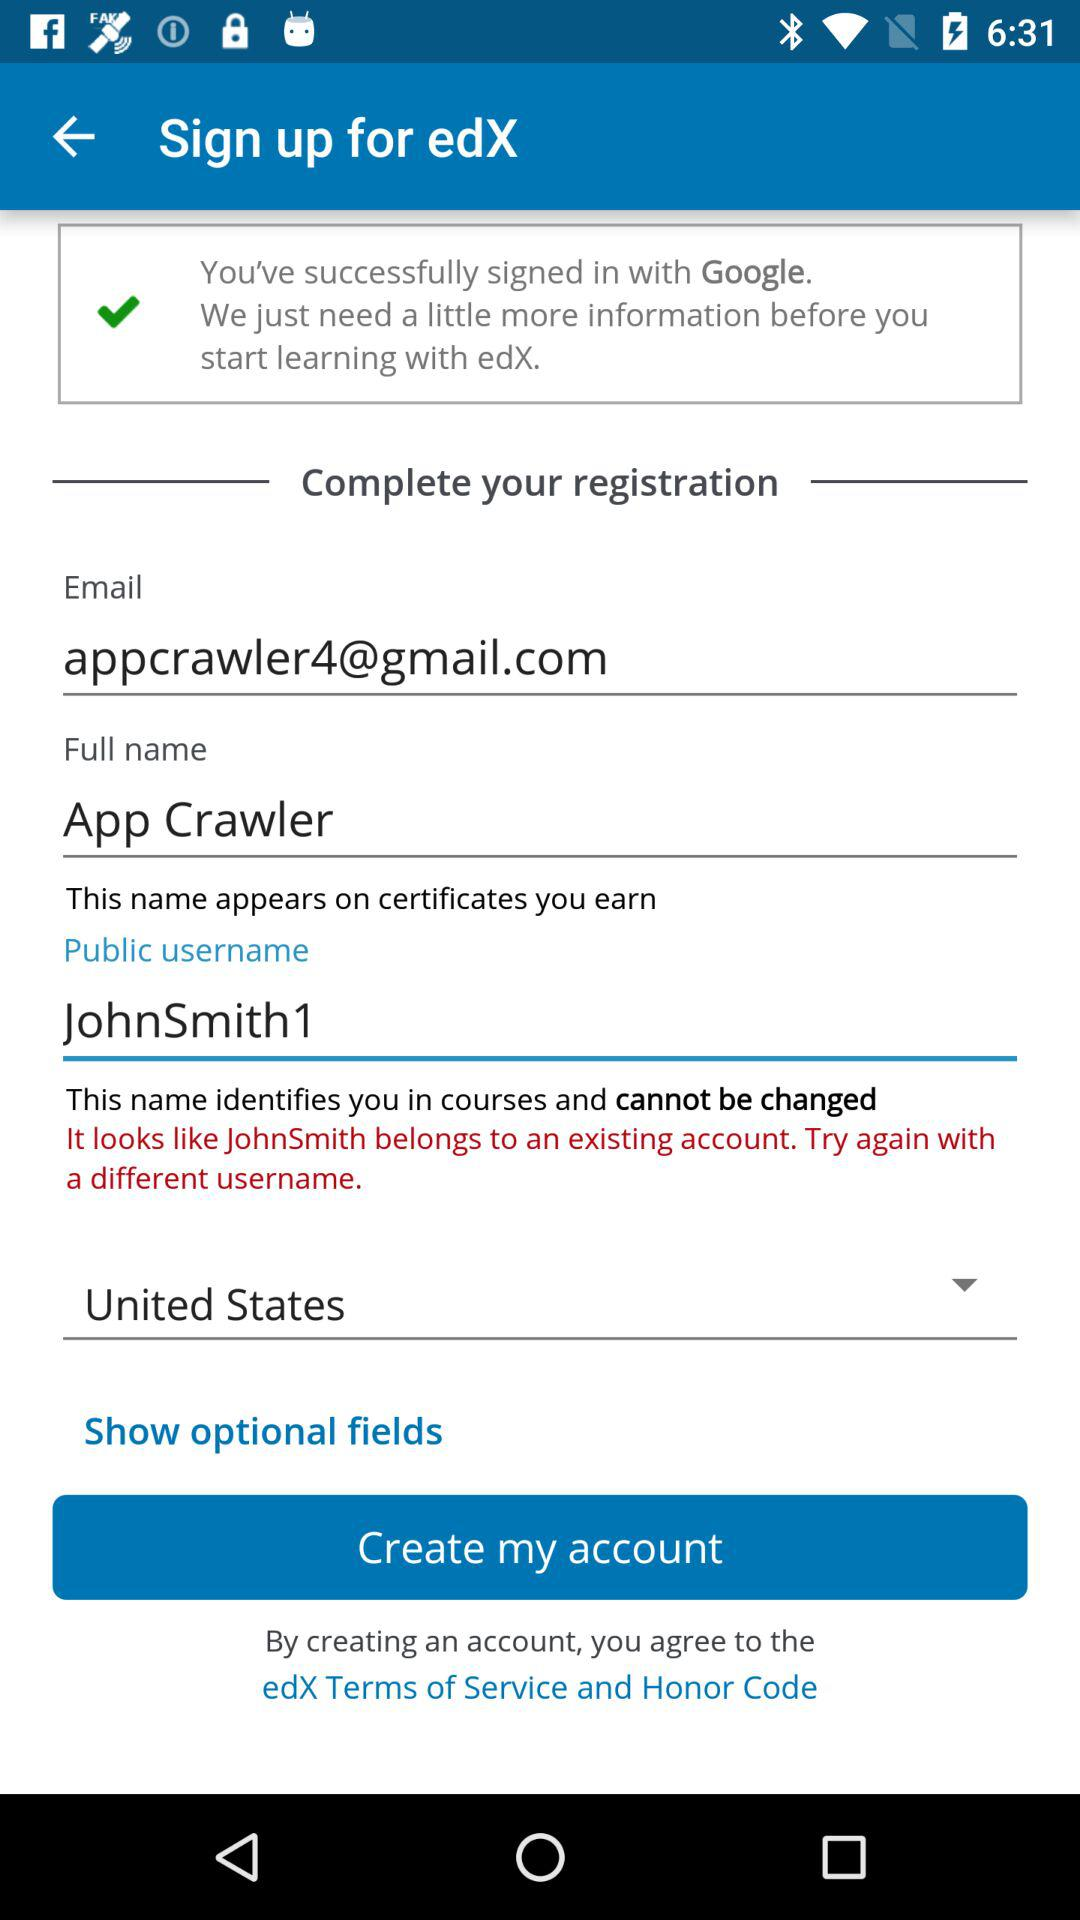What is the full name? The full name is App Crawler. 